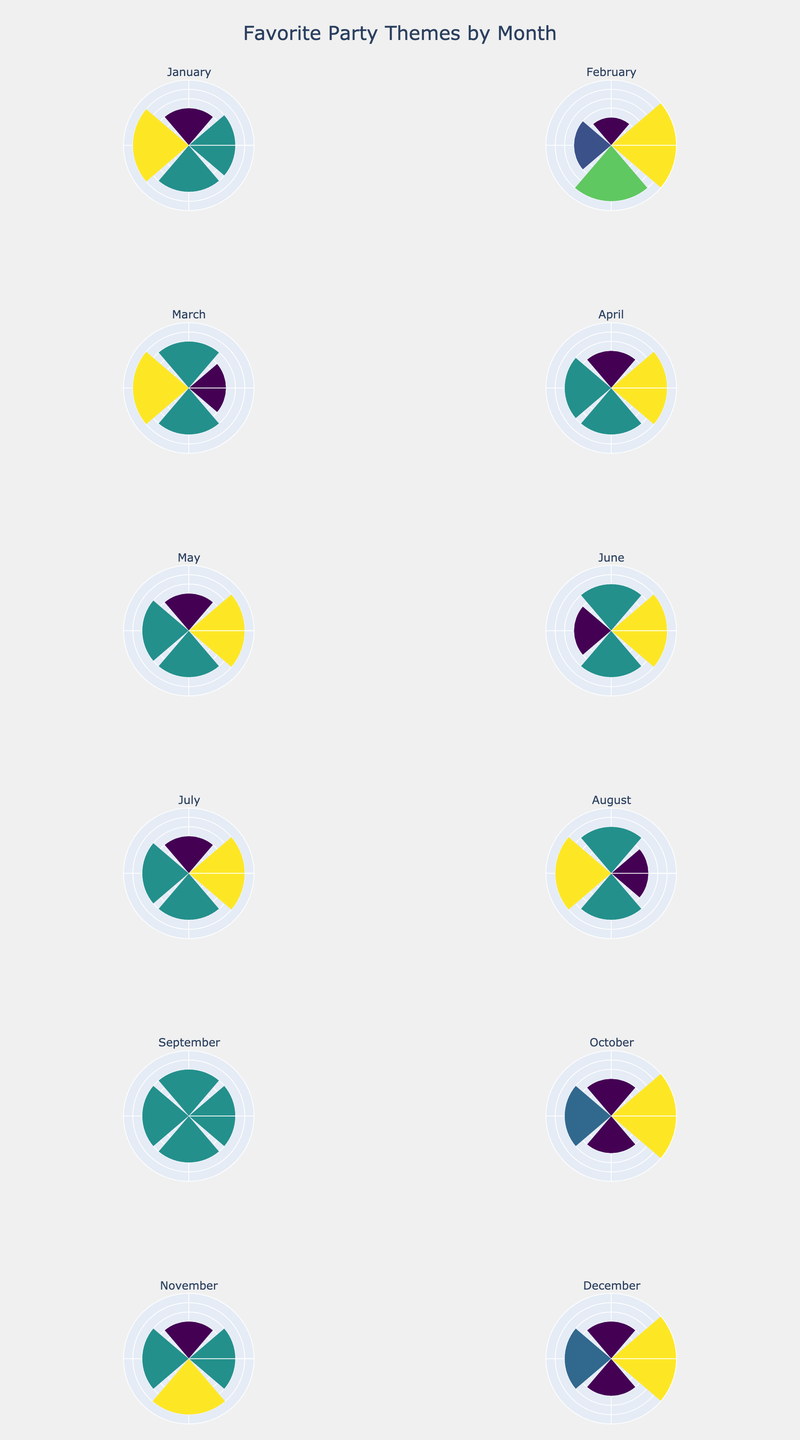What's the title of the figure? The title is typically found at the top of the figure. In this figure, it is mentioned in the provided code.
Answer: Favorite Party Themes by Month How many party themes are shown for the month of January? In the plot for January, look at the number of bars representing different themes.
Answer: 4 Which month has the most popular party theme, and what is it? Identify the bar with the highest value in any subplot. The highest value is 35, found in both February and December, representing Valentine’s Day and Christmas, respectively.
Answer: February, Valentine’s Day and December, Christmas Which theme is consistently popular across multiple months? Look for a theme that appears multiple times across different monthly subplots.
Answer: Superheroes How much more popular is the Halloween theme in October compared to the Superheroes theme in the same month? Subtract the popularity of the Superheroes theme from the popularity of the Halloween theme in October's subplot.
Answer: 15 During which months does the Winter Wonderland theme appear, and what is its popularity in those months? Identify the subplots containing Winter Wonderland and note its popularity. It appears in January and December with a popularity of 25 each.
Answer: January (25), December (25) In which month does the "Harry Potter" theme appear, and what is its popularity? Locate the subplot that includes the "Harry Potter" theme and read its value.
Answer: February (30), October (25) Which month has the least popular theme, and what is it? Find the smallest value across all subplots and note the theme and month. The smallest value is 15, found in February for the Superheroes theme.
Answer: February, Superheroes How many themes have a popularity of 30? Count the number of bars with a value of 30 across all subplots.
Answer: 10 How do the popular themes in June compare to those in July? Observe the themes in June and July subplots and specify the differences. June has Beach Party, Lego, Superheroes, and Unicorn. July has 4th of July, Superheroes, Camping, and Wizard and Magic. Superheroes are common in both months.
Answer: June: Beach Party, Lego, Superheroes, Unicorn; July: 4th of July, Superheroes, Camping, Wizard and Magic 